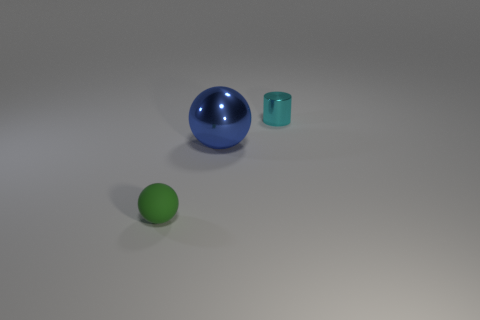Add 1 small yellow shiny cubes. How many objects exist? 4 Subtract all brown cylinders. How many green balls are left? 1 Add 3 yellow cylinders. How many yellow cylinders exist? 3 Subtract 0 brown cylinders. How many objects are left? 3 Subtract all cylinders. How many objects are left? 2 Subtract 1 cylinders. How many cylinders are left? 0 Subtract all blue balls. Subtract all red blocks. How many balls are left? 1 Subtract all rubber spheres. Subtract all small cyan metal things. How many objects are left? 1 Add 3 tiny cyan things. How many tiny cyan things are left? 4 